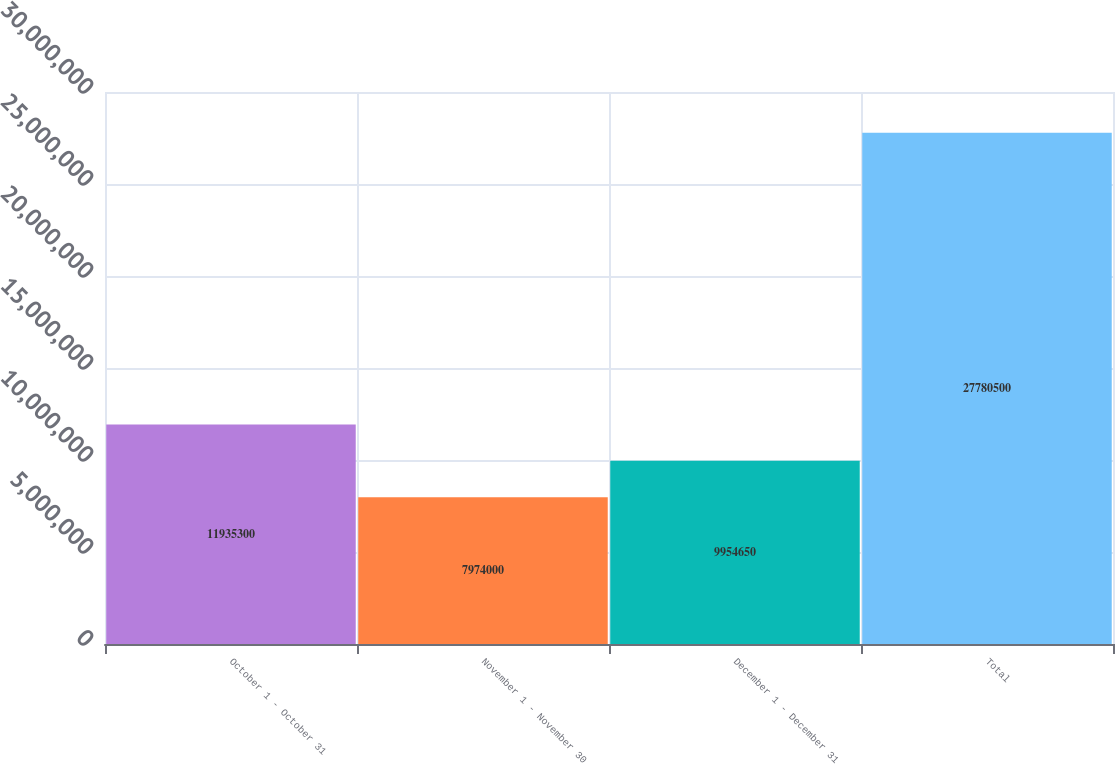<chart> <loc_0><loc_0><loc_500><loc_500><bar_chart><fcel>October 1 - October 31<fcel>November 1 - November 30<fcel>December 1 - December 31<fcel>Total<nl><fcel>1.19353e+07<fcel>7.974e+06<fcel>9.95465e+06<fcel>2.77805e+07<nl></chart> 